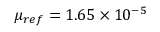<formula> <loc_0><loc_0><loc_500><loc_500>\mu _ { r e f } = 1 . 6 5 \times 1 0 ^ { - 5 }</formula> 